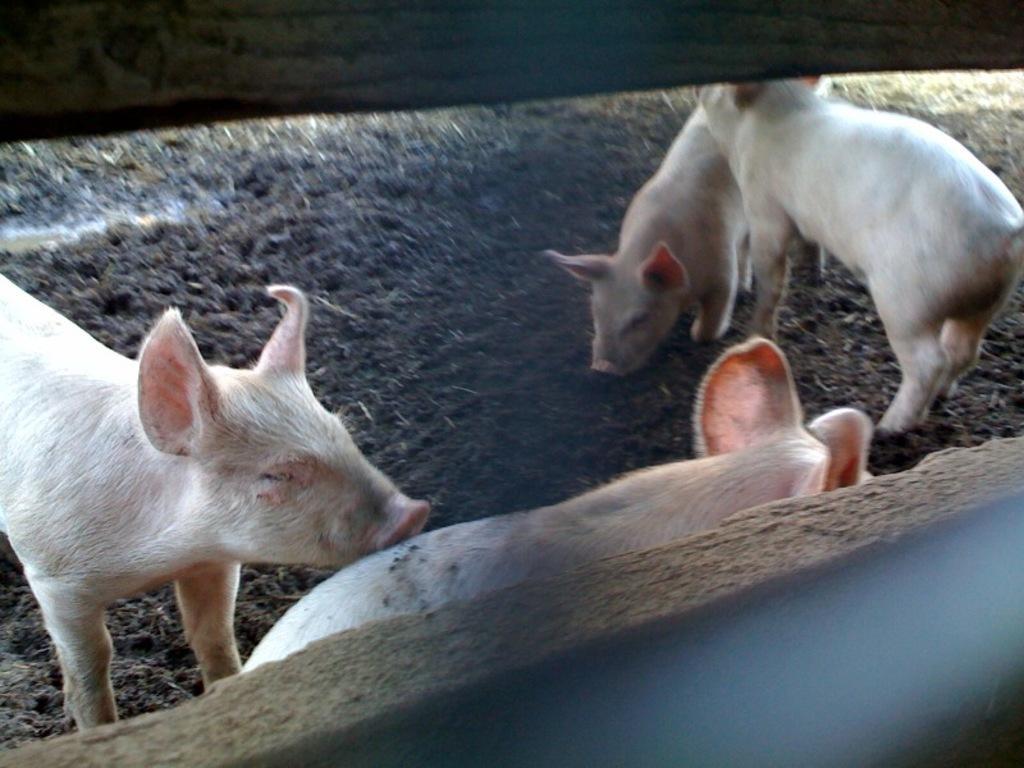Can you describe this image briefly? Here we can see four pigs standing on the ground and this is a fence. 